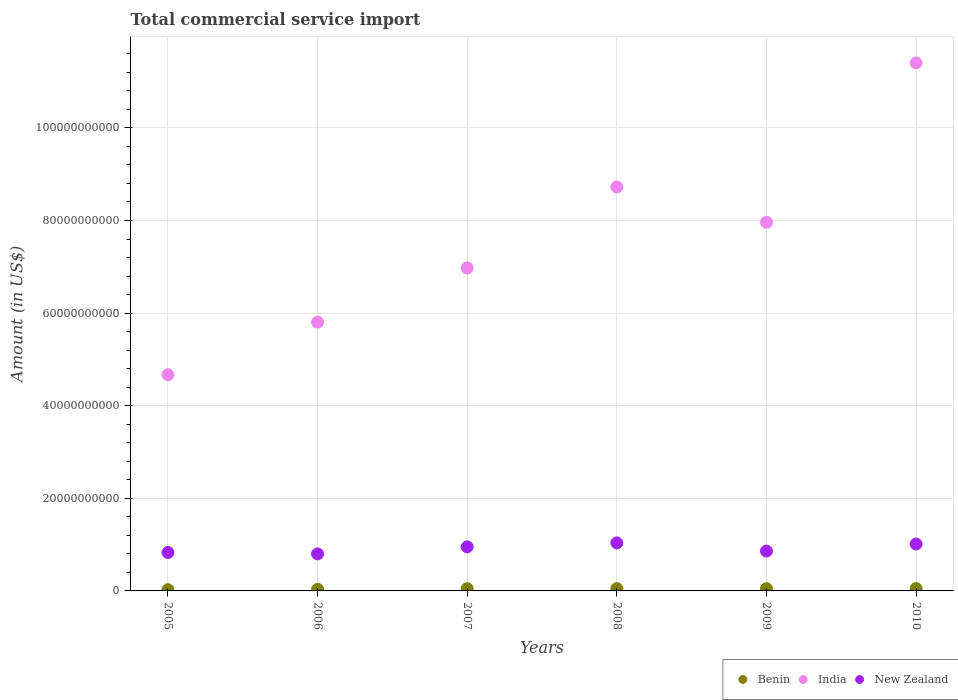How many different coloured dotlines are there?
Your answer should be very brief. 3. Is the number of dotlines equal to the number of legend labels?
Offer a terse response. Yes. What is the total commercial service import in India in 2008?
Your answer should be compact. 8.72e+1. Across all years, what is the maximum total commercial service import in India?
Provide a short and direct response. 1.14e+11. Across all years, what is the minimum total commercial service import in New Zealand?
Ensure brevity in your answer.  8.00e+09. What is the total total commercial service import in New Zealand in the graph?
Provide a succinct answer. 5.49e+1. What is the difference between the total commercial service import in New Zealand in 2005 and that in 2009?
Provide a succinct answer. -2.95e+08. What is the difference between the total commercial service import in India in 2007 and the total commercial service import in Benin in 2008?
Provide a succinct answer. 6.93e+1. What is the average total commercial service import in Benin per year?
Offer a terse response. 4.33e+08. In the year 2006, what is the difference between the total commercial service import in New Zealand and total commercial service import in India?
Make the answer very short. -5.00e+1. In how many years, is the total commercial service import in New Zealand greater than 84000000000 US$?
Your answer should be very brief. 0. What is the ratio of the total commercial service import in New Zealand in 2005 to that in 2008?
Offer a terse response. 0.8. Is the difference between the total commercial service import in New Zealand in 2005 and 2007 greater than the difference between the total commercial service import in India in 2005 and 2007?
Give a very brief answer. Yes. What is the difference between the highest and the second highest total commercial service import in India?
Offer a terse response. 2.68e+1. What is the difference between the highest and the lowest total commercial service import in New Zealand?
Ensure brevity in your answer.  2.37e+09. Is the sum of the total commercial service import in India in 2007 and 2010 greater than the maximum total commercial service import in Benin across all years?
Ensure brevity in your answer.  Yes. Is it the case that in every year, the sum of the total commercial service import in Benin and total commercial service import in New Zealand  is greater than the total commercial service import in India?
Make the answer very short. No. Does the total commercial service import in India monotonically increase over the years?
Your answer should be very brief. No. Is the total commercial service import in Benin strictly greater than the total commercial service import in New Zealand over the years?
Provide a short and direct response. No. How many dotlines are there?
Give a very brief answer. 3. How many years are there in the graph?
Give a very brief answer. 6. Are the values on the major ticks of Y-axis written in scientific E-notation?
Keep it short and to the point. No. Does the graph contain any zero values?
Your answer should be compact. No. Where does the legend appear in the graph?
Provide a short and direct response. Bottom right. How many legend labels are there?
Your response must be concise. 3. How are the legend labels stacked?
Ensure brevity in your answer.  Horizontal. What is the title of the graph?
Your answer should be compact. Total commercial service import. What is the label or title of the Y-axis?
Make the answer very short. Amount (in US$). What is the Amount (in US$) in Benin in 2005?
Provide a succinct answer. 2.69e+08. What is the Amount (in US$) in India in 2005?
Keep it short and to the point. 4.67e+1. What is the Amount (in US$) of New Zealand in 2005?
Provide a succinct answer. 8.30e+09. What is the Amount (in US$) of Benin in 2006?
Offer a very short reply. 3.46e+08. What is the Amount (in US$) in India in 2006?
Your answer should be compact. 5.80e+1. What is the Amount (in US$) in New Zealand in 2006?
Make the answer very short. 8.00e+09. What is the Amount (in US$) in Benin in 2007?
Offer a very short reply. 4.91e+08. What is the Amount (in US$) in India in 2007?
Provide a succinct answer. 6.98e+1. What is the Amount (in US$) of New Zealand in 2007?
Your response must be concise. 9.52e+09. What is the Amount (in US$) of Benin in 2008?
Offer a very short reply. 5.00e+08. What is the Amount (in US$) in India in 2008?
Ensure brevity in your answer.  8.72e+1. What is the Amount (in US$) of New Zealand in 2008?
Provide a short and direct response. 1.04e+1. What is the Amount (in US$) of Benin in 2009?
Offer a very short reply. 4.88e+08. What is the Amount (in US$) of India in 2009?
Provide a short and direct response. 7.96e+1. What is the Amount (in US$) in New Zealand in 2009?
Keep it short and to the point. 8.60e+09. What is the Amount (in US$) of Benin in 2010?
Provide a short and direct response. 5.03e+08. What is the Amount (in US$) of India in 2010?
Your response must be concise. 1.14e+11. What is the Amount (in US$) of New Zealand in 2010?
Offer a terse response. 1.01e+1. Across all years, what is the maximum Amount (in US$) in Benin?
Your response must be concise. 5.03e+08. Across all years, what is the maximum Amount (in US$) of India?
Offer a very short reply. 1.14e+11. Across all years, what is the maximum Amount (in US$) in New Zealand?
Your response must be concise. 1.04e+1. Across all years, what is the minimum Amount (in US$) of Benin?
Give a very brief answer. 2.69e+08. Across all years, what is the minimum Amount (in US$) in India?
Your response must be concise. 4.67e+1. Across all years, what is the minimum Amount (in US$) in New Zealand?
Your response must be concise. 8.00e+09. What is the total Amount (in US$) of Benin in the graph?
Make the answer very short. 2.60e+09. What is the total Amount (in US$) in India in the graph?
Your answer should be compact. 4.55e+11. What is the total Amount (in US$) in New Zealand in the graph?
Keep it short and to the point. 5.49e+1. What is the difference between the Amount (in US$) in Benin in 2005 and that in 2006?
Offer a terse response. -7.67e+07. What is the difference between the Amount (in US$) in India in 2005 and that in 2006?
Ensure brevity in your answer.  -1.13e+1. What is the difference between the Amount (in US$) of New Zealand in 2005 and that in 2006?
Your answer should be compact. 3.07e+08. What is the difference between the Amount (in US$) in Benin in 2005 and that in 2007?
Offer a terse response. -2.22e+08. What is the difference between the Amount (in US$) of India in 2005 and that in 2007?
Provide a succinct answer. -2.31e+1. What is the difference between the Amount (in US$) of New Zealand in 2005 and that in 2007?
Keep it short and to the point. -1.21e+09. What is the difference between the Amount (in US$) in Benin in 2005 and that in 2008?
Your response must be concise. -2.31e+08. What is the difference between the Amount (in US$) of India in 2005 and that in 2008?
Your response must be concise. -4.05e+1. What is the difference between the Amount (in US$) of New Zealand in 2005 and that in 2008?
Give a very brief answer. -2.07e+09. What is the difference between the Amount (in US$) in Benin in 2005 and that in 2009?
Offer a very short reply. -2.19e+08. What is the difference between the Amount (in US$) in India in 2005 and that in 2009?
Offer a very short reply. -3.29e+1. What is the difference between the Amount (in US$) of New Zealand in 2005 and that in 2009?
Make the answer very short. -2.95e+08. What is the difference between the Amount (in US$) in Benin in 2005 and that in 2010?
Your answer should be compact. -2.34e+08. What is the difference between the Amount (in US$) in India in 2005 and that in 2010?
Offer a terse response. -6.73e+1. What is the difference between the Amount (in US$) in New Zealand in 2005 and that in 2010?
Offer a terse response. -1.83e+09. What is the difference between the Amount (in US$) of Benin in 2006 and that in 2007?
Offer a terse response. -1.45e+08. What is the difference between the Amount (in US$) in India in 2006 and that in 2007?
Give a very brief answer. -1.17e+1. What is the difference between the Amount (in US$) in New Zealand in 2006 and that in 2007?
Your answer should be compact. -1.52e+09. What is the difference between the Amount (in US$) of Benin in 2006 and that in 2008?
Your response must be concise. -1.54e+08. What is the difference between the Amount (in US$) of India in 2006 and that in 2008?
Offer a terse response. -2.92e+1. What is the difference between the Amount (in US$) of New Zealand in 2006 and that in 2008?
Your answer should be compact. -2.37e+09. What is the difference between the Amount (in US$) in Benin in 2006 and that in 2009?
Keep it short and to the point. -1.42e+08. What is the difference between the Amount (in US$) in India in 2006 and that in 2009?
Your answer should be compact. -2.16e+1. What is the difference between the Amount (in US$) of New Zealand in 2006 and that in 2009?
Provide a succinct answer. -6.02e+08. What is the difference between the Amount (in US$) of Benin in 2006 and that in 2010?
Provide a succinct answer. -1.57e+08. What is the difference between the Amount (in US$) in India in 2006 and that in 2010?
Your answer should be compact. -5.60e+1. What is the difference between the Amount (in US$) of New Zealand in 2006 and that in 2010?
Your response must be concise. -2.13e+09. What is the difference between the Amount (in US$) in Benin in 2007 and that in 2008?
Ensure brevity in your answer.  -8.76e+06. What is the difference between the Amount (in US$) in India in 2007 and that in 2008?
Keep it short and to the point. -1.75e+1. What is the difference between the Amount (in US$) in New Zealand in 2007 and that in 2008?
Give a very brief answer. -8.51e+08. What is the difference between the Amount (in US$) of Benin in 2007 and that in 2009?
Offer a very short reply. 3.08e+06. What is the difference between the Amount (in US$) in India in 2007 and that in 2009?
Keep it short and to the point. -9.87e+09. What is the difference between the Amount (in US$) of New Zealand in 2007 and that in 2009?
Ensure brevity in your answer.  9.20e+08. What is the difference between the Amount (in US$) of Benin in 2007 and that in 2010?
Make the answer very short. -1.16e+07. What is the difference between the Amount (in US$) in India in 2007 and that in 2010?
Make the answer very short. -4.43e+1. What is the difference between the Amount (in US$) in New Zealand in 2007 and that in 2010?
Make the answer very short. -6.12e+08. What is the difference between the Amount (in US$) of Benin in 2008 and that in 2009?
Give a very brief answer. 1.18e+07. What is the difference between the Amount (in US$) of India in 2008 and that in 2009?
Offer a terse response. 7.61e+09. What is the difference between the Amount (in US$) in New Zealand in 2008 and that in 2009?
Give a very brief answer. 1.77e+09. What is the difference between the Amount (in US$) in Benin in 2008 and that in 2010?
Make the answer very short. -2.87e+06. What is the difference between the Amount (in US$) in India in 2008 and that in 2010?
Give a very brief answer. -2.68e+1. What is the difference between the Amount (in US$) in New Zealand in 2008 and that in 2010?
Keep it short and to the point. 2.39e+08. What is the difference between the Amount (in US$) in Benin in 2009 and that in 2010?
Your response must be concise. -1.47e+07. What is the difference between the Amount (in US$) in India in 2009 and that in 2010?
Offer a terse response. -3.44e+1. What is the difference between the Amount (in US$) in New Zealand in 2009 and that in 2010?
Ensure brevity in your answer.  -1.53e+09. What is the difference between the Amount (in US$) in Benin in 2005 and the Amount (in US$) in India in 2006?
Provide a short and direct response. -5.78e+1. What is the difference between the Amount (in US$) in Benin in 2005 and the Amount (in US$) in New Zealand in 2006?
Give a very brief answer. -7.73e+09. What is the difference between the Amount (in US$) of India in 2005 and the Amount (in US$) of New Zealand in 2006?
Provide a succinct answer. 3.87e+1. What is the difference between the Amount (in US$) in Benin in 2005 and the Amount (in US$) in India in 2007?
Provide a short and direct response. -6.95e+1. What is the difference between the Amount (in US$) of Benin in 2005 and the Amount (in US$) of New Zealand in 2007?
Provide a short and direct response. -9.25e+09. What is the difference between the Amount (in US$) of India in 2005 and the Amount (in US$) of New Zealand in 2007?
Your answer should be compact. 3.72e+1. What is the difference between the Amount (in US$) in Benin in 2005 and the Amount (in US$) in India in 2008?
Offer a terse response. -8.70e+1. What is the difference between the Amount (in US$) in Benin in 2005 and the Amount (in US$) in New Zealand in 2008?
Your response must be concise. -1.01e+1. What is the difference between the Amount (in US$) of India in 2005 and the Amount (in US$) of New Zealand in 2008?
Make the answer very short. 3.63e+1. What is the difference between the Amount (in US$) of Benin in 2005 and the Amount (in US$) of India in 2009?
Offer a terse response. -7.94e+1. What is the difference between the Amount (in US$) of Benin in 2005 and the Amount (in US$) of New Zealand in 2009?
Keep it short and to the point. -8.33e+09. What is the difference between the Amount (in US$) of India in 2005 and the Amount (in US$) of New Zealand in 2009?
Your answer should be compact. 3.81e+1. What is the difference between the Amount (in US$) in Benin in 2005 and the Amount (in US$) in India in 2010?
Ensure brevity in your answer.  -1.14e+11. What is the difference between the Amount (in US$) in Benin in 2005 and the Amount (in US$) in New Zealand in 2010?
Your answer should be very brief. -9.86e+09. What is the difference between the Amount (in US$) in India in 2005 and the Amount (in US$) in New Zealand in 2010?
Your answer should be very brief. 3.66e+1. What is the difference between the Amount (in US$) in Benin in 2006 and the Amount (in US$) in India in 2007?
Keep it short and to the point. -6.94e+1. What is the difference between the Amount (in US$) in Benin in 2006 and the Amount (in US$) in New Zealand in 2007?
Keep it short and to the point. -9.17e+09. What is the difference between the Amount (in US$) of India in 2006 and the Amount (in US$) of New Zealand in 2007?
Offer a very short reply. 4.85e+1. What is the difference between the Amount (in US$) in Benin in 2006 and the Amount (in US$) in India in 2008?
Provide a short and direct response. -8.69e+1. What is the difference between the Amount (in US$) in Benin in 2006 and the Amount (in US$) in New Zealand in 2008?
Offer a very short reply. -1.00e+1. What is the difference between the Amount (in US$) of India in 2006 and the Amount (in US$) of New Zealand in 2008?
Ensure brevity in your answer.  4.77e+1. What is the difference between the Amount (in US$) in Benin in 2006 and the Amount (in US$) in India in 2009?
Keep it short and to the point. -7.93e+1. What is the difference between the Amount (in US$) in Benin in 2006 and the Amount (in US$) in New Zealand in 2009?
Provide a short and direct response. -8.25e+09. What is the difference between the Amount (in US$) of India in 2006 and the Amount (in US$) of New Zealand in 2009?
Offer a very short reply. 4.94e+1. What is the difference between the Amount (in US$) in Benin in 2006 and the Amount (in US$) in India in 2010?
Keep it short and to the point. -1.14e+11. What is the difference between the Amount (in US$) in Benin in 2006 and the Amount (in US$) in New Zealand in 2010?
Your response must be concise. -9.79e+09. What is the difference between the Amount (in US$) of India in 2006 and the Amount (in US$) of New Zealand in 2010?
Give a very brief answer. 4.79e+1. What is the difference between the Amount (in US$) of Benin in 2007 and the Amount (in US$) of India in 2008?
Provide a succinct answer. -8.67e+1. What is the difference between the Amount (in US$) in Benin in 2007 and the Amount (in US$) in New Zealand in 2008?
Your answer should be very brief. -9.88e+09. What is the difference between the Amount (in US$) of India in 2007 and the Amount (in US$) of New Zealand in 2008?
Provide a short and direct response. 5.94e+1. What is the difference between the Amount (in US$) of Benin in 2007 and the Amount (in US$) of India in 2009?
Offer a terse response. -7.91e+1. What is the difference between the Amount (in US$) in Benin in 2007 and the Amount (in US$) in New Zealand in 2009?
Make the answer very short. -8.11e+09. What is the difference between the Amount (in US$) in India in 2007 and the Amount (in US$) in New Zealand in 2009?
Offer a terse response. 6.12e+1. What is the difference between the Amount (in US$) in Benin in 2007 and the Amount (in US$) in India in 2010?
Your answer should be very brief. -1.14e+11. What is the difference between the Amount (in US$) in Benin in 2007 and the Amount (in US$) in New Zealand in 2010?
Your answer should be compact. -9.64e+09. What is the difference between the Amount (in US$) in India in 2007 and the Amount (in US$) in New Zealand in 2010?
Provide a succinct answer. 5.96e+1. What is the difference between the Amount (in US$) in Benin in 2008 and the Amount (in US$) in India in 2009?
Offer a terse response. -7.91e+1. What is the difference between the Amount (in US$) of Benin in 2008 and the Amount (in US$) of New Zealand in 2009?
Ensure brevity in your answer.  -8.10e+09. What is the difference between the Amount (in US$) of India in 2008 and the Amount (in US$) of New Zealand in 2009?
Your response must be concise. 7.86e+1. What is the difference between the Amount (in US$) in Benin in 2008 and the Amount (in US$) in India in 2010?
Provide a succinct answer. -1.14e+11. What is the difference between the Amount (in US$) of Benin in 2008 and the Amount (in US$) of New Zealand in 2010?
Give a very brief answer. -9.63e+09. What is the difference between the Amount (in US$) in India in 2008 and the Amount (in US$) in New Zealand in 2010?
Provide a short and direct response. 7.71e+1. What is the difference between the Amount (in US$) of Benin in 2009 and the Amount (in US$) of India in 2010?
Offer a very short reply. -1.14e+11. What is the difference between the Amount (in US$) in Benin in 2009 and the Amount (in US$) in New Zealand in 2010?
Give a very brief answer. -9.64e+09. What is the difference between the Amount (in US$) of India in 2009 and the Amount (in US$) of New Zealand in 2010?
Provide a short and direct response. 6.95e+1. What is the average Amount (in US$) in Benin per year?
Make the answer very short. 4.33e+08. What is the average Amount (in US$) of India per year?
Provide a succinct answer. 7.59e+1. What is the average Amount (in US$) in New Zealand per year?
Offer a terse response. 9.15e+09. In the year 2005, what is the difference between the Amount (in US$) of Benin and Amount (in US$) of India?
Make the answer very short. -4.64e+1. In the year 2005, what is the difference between the Amount (in US$) of Benin and Amount (in US$) of New Zealand?
Offer a very short reply. -8.03e+09. In the year 2005, what is the difference between the Amount (in US$) of India and Amount (in US$) of New Zealand?
Make the answer very short. 3.84e+1. In the year 2006, what is the difference between the Amount (in US$) of Benin and Amount (in US$) of India?
Provide a succinct answer. -5.77e+1. In the year 2006, what is the difference between the Amount (in US$) of Benin and Amount (in US$) of New Zealand?
Your answer should be compact. -7.65e+09. In the year 2006, what is the difference between the Amount (in US$) in India and Amount (in US$) in New Zealand?
Make the answer very short. 5.00e+1. In the year 2007, what is the difference between the Amount (in US$) of Benin and Amount (in US$) of India?
Make the answer very short. -6.93e+1. In the year 2007, what is the difference between the Amount (in US$) of Benin and Amount (in US$) of New Zealand?
Your answer should be compact. -9.03e+09. In the year 2007, what is the difference between the Amount (in US$) of India and Amount (in US$) of New Zealand?
Give a very brief answer. 6.02e+1. In the year 2008, what is the difference between the Amount (in US$) in Benin and Amount (in US$) in India?
Your answer should be compact. -8.67e+1. In the year 2008, what is the difference between the Amount (in US$) in Benin and Amount (in US$) in New Zealand?
Offer a very short reply. -9.87e+09. In the year 2008, what is the difference between the Amount (in US$) of India and Amount (in US$) of New Zealand?
Ensure brevity in your answer.  7.69e+1. In the year 2009, what is the difference between the Amount (in US$) in Benin and Amount (in US$) in India?
Make the answer very short. -7.91e+1. In the year 2009, what is the difference between the Amount (in US$) of Benin and Amount (in US$) of New Zealand?
Keep it short and to the point. -8.11e+09. In the year 2009, what is the difference between the Amount (in US$) of India and Amount (in US$) of New Zealand?
Your response must be concise. 7.10e+1. In the year 2010, what is the difference between the Amount (in US$) of Benin and Amount (in US$) of India?
Offer a terse response. -1.14e+11. In the year 2010, what is the difference between the Amount (in US$) in Benin and Amount (in US$) in New Zealand?
Make the answer very short. -9.63e+09. In the year 2010, what is the difference between the Amount (in US$) of India and Amount (in US$) of New Zealand?
Your answer should be compact. 1.04e+11. What is the ratio of the Amount (in US$) of Benin in 2005 to that in 2006?
Give a very brief answer. 0.78. What is the ratio of the Amount (in US$) of India in 2005 to that in 2006?
Provide a succinct answer. 0.8. What is the ratio of the Amount (in US$) in New Zealand in 2005 to that in 2006?
Your answer should be compact. 1.04. What is the ratio of the Amount (in US$) of Benin in 2005 to that in 2007?
Ensure brevity in your answer.  0.55. What is the ratio of the Amount (in US$) of India in 2005 to that in 2007?
Provide a short and direct response. 0.67. What is the ratio of the Amount (in US$) of New Zealand in 2005 to that in 2007?
Your response must be concise. 0.87. What is the ratio of the Amount (in US$) of Benin in 2005 to that in 2008?
Ensure brevity in your answer.  0.54. What is the ratio of the Amount (in US$) in India in 2005 to that in 2008?
Make the answer very short. 0.54. What is the ratio of the Amount (in US$) in New Zealand in 2005 to that in 2008?
Your answer should be very brief. 0.8. What is the ratio of the Amount (in US$) of Benin in 2005 to that in 2009?
Provide a short and direct response. 0.55. What is the ratio of the Amount (in US$) of India in 2005 to that in 2009?
Your answer should be compact. 0.59. What is the ratio of the Amount (in US$) of New Zealand in 2005 to that in 2009?
Your response must be concise. 0.97. What is the ratio of the Amount (in US$) of Benin in 2005 to that in 2010?
Provide a succinct answer. 0.54. What is the ratio of the Amount (in US$) in India in 2005 to that in 2010?
Provide a short and direct response. 0.41. What is the ratio of the Amount (in US$) of New Zealand in 2005 to that in 2010?
Offer a very short reply. 0.82. What is the ratio of the Amount (in US$) in Benin in 2006 to that in 2007?
Provide a succinct answer. 0.7. What is the ratio of the Amount (in US$) of India in 2006 to that in 2007?
Ensure brevity in your answer.  0.83. What is the ratio of the Amount (in US$) in New Zealand in 2006 to that in 2007?
Provide a succinct answer. 0.84. What is the ratio of the Amount (in US$) of Benin in 2006 to that in 2008?
Provide a short and direct response. 0.69. What is the ratio of the Amount (in US$) in India in 2006 to that in 2008?
Ensure brevity in your answer.  0.67. What is the ratio of the Amount (in US$) of New Zealand in 2006 to that in 2008?
Your answer should be very brief. 0.77. What is the ratio of the Amount (in US$) in Benin in 2006 to that in 2009?
Ensure brevity in your answer.  0.71. What is the ratio of the Amount (in US$) of India in 2006 to that in 2009?
Your response must be concise. 0.73. What is the ratio of the Amount (in US$) in New Zealand in 2006 to that in 2009?
Ensure brevity in your answer.  0.93. What is the ratio of the Amount (in US$) of Benin in 2006 to that in 2010?
Your response must be concise. 0.69. What is the ratio of the Amount (in US$) in India in 2006 to that in 2010?
Give a very brief answer. 0.51. What is the ratio of the Amount (in US$) in New Zealand in 2006 to that in 2010?
Your response must be concise. 0.79. What is the ratio of the Amount (in US$) in Benin in 2007 to that in 2008?
Provide a succinct answer. 0.98. What is the ratio of the Amount (in US$) of India in 2007 to that in 2008?
Make the answer very short. 0.8. What is the ratio of the Amount (in US$) of New Zealand in 2007 to that in 2008?
Your answer should be very brief. 0.92. What is the ratio of the Amount (in US$) in Benin in 2007 to that in 2009?
Keep it short and to the point. 1.01. What is the ratio of the Amount (in US$) in India in 2007 to that in 2009?
Your answer should be very brief. 0.88. What is the ratio of the Amount (in US$) of New Zealand in 2007 to that in 2009?
Your answer should be compact. 1.11. What is the ratio of the Amount (in US$) of Benin in 2007 to that in 2010?
Ensure brevity in your answer.  0.98. What is the ratio of the Amount (in US$) of India in 2007 to that in 2010?
Provide a succinct answer. 0.61. What is the ratio of the Amount (in US$) of New Zealand in 2007 to that in 2010?
Offer a very short reply. 0.94. What is the ratio of the Amount (in US$) of Benin in 2008 to that in 2009?
Give a very brief answer. 1.02. What is the ratio of the Amount (in US$) in India in 2008 to that in 2009?
Provide a short and direct response. 1.1. What is the ratio of the Amount (in US$) in New Zealand in 2008 to that in 2009?
Provide a short and direct response. 1.21. What is the ratio of the Amount (in US$) in India in 2008 to that in 2010?
Offer a very short reply. 0.77. What is the ratio of the Amount (in US$) in New Zealand in 2008 to that in 2010?
Your answer should be compact. 1.02. What is the ratio of the Amount (in US$) in Benin in 2009 to that in 2010?
Your answer should be very brief. 0.97. What is the ratio of the Amount (in US$) of India in 2009 to that in 2010?
Make the answer very short. 0.7. What is the ratio of the Amount (in US$) of New Zealand in 2009 to that in 2010?
Give a very brief answer. 0.85. What is the difference between the highest and the second highest Amount (in US$) in Benin?
Make the answer very short. 2.87e+06. What is the difference between the highest and the second highest Amount (in US$) of India?
Give a very brief answer. 2.68e+1. What is the difference between the highest and the second highest Amount (in US$) of New Zealand?
Provide a succinct answer. 2.39e+08. What is the difference between the highest and the lowest Amount (in US$) of Benin?
Ensure brevity in your answer.  2.34e+08. What is the difference between the highest and the lowest Amount (in US$) of India?
Ensure brevity in your answer.  6.73e+1. What is the difference between the highest and the lowest Amount (in US$) in New Zealand?
Provide a succinct answer. 2.37e+09. 